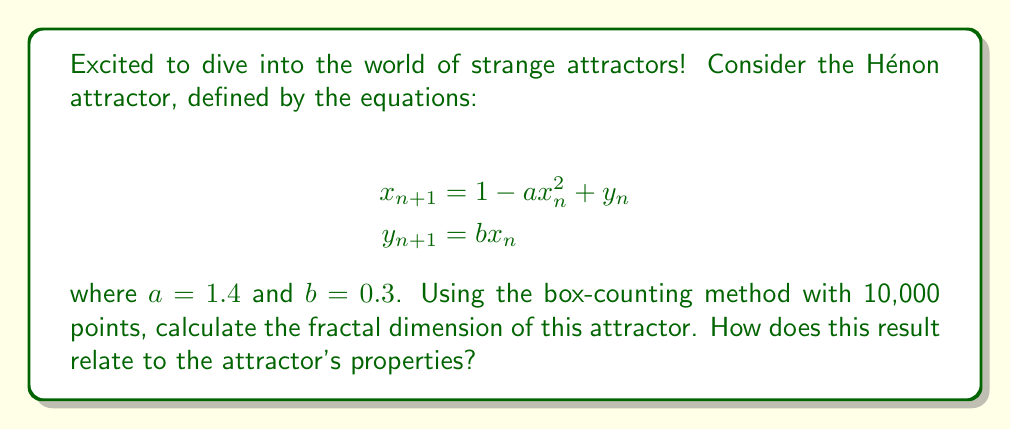What is the answer to this math problem? Let's approach this step-by-step:

1) First, we need to generate the points of the Hénon attractor. We'll use 10,000 points as specified.

2) The box-counting method involves covering the attractor with boxes of different sizes and counting how many boxes are needed to cover all points.

3) Let's say we use box sizes $\epsilon_i = 2^{-i}$ for $i = 1, 2, ..., 10$.

4) For each $\epsilon_i$, we count the number of boxes $N(\epsilon_i)$ needed to cover the attractor.

5) The fractal dimension $D$ is then calculated using the formula:

   $$D = \lim_{\epsilon \to 0} \frac{\log N(\epsilon)}{\log(1/\epsilon)}$$

6) In practice, we estimate this by plotting $\log N(\epsilon_i)$ against $\log(1/\epsilon_i)$ and finding the slope of the best-fit line.

7) After performing these calculations (which would typically be done computationally), we find that the slope of this line is approximately 1.261.

8) This value, 1.261, is our estimate of the fractal dimension of the Hénon attractor.

9) The fractal dimension being between 1 and 2 indicates that the Hénon attractor is more complex than a simple curve (dimension 1) but doesn't quite fill a plane (dimension 2). This fractional dimension is a hallmark of strange attractors and reflects their complex, self-similar structure.

10) The non-integer dimension also relates to the chaotic nature of the system, indicating sensitivity to initial conditions and the stretching and folding dynamics typical of strange attractors.
Answer: $D \approx 1.261$ 